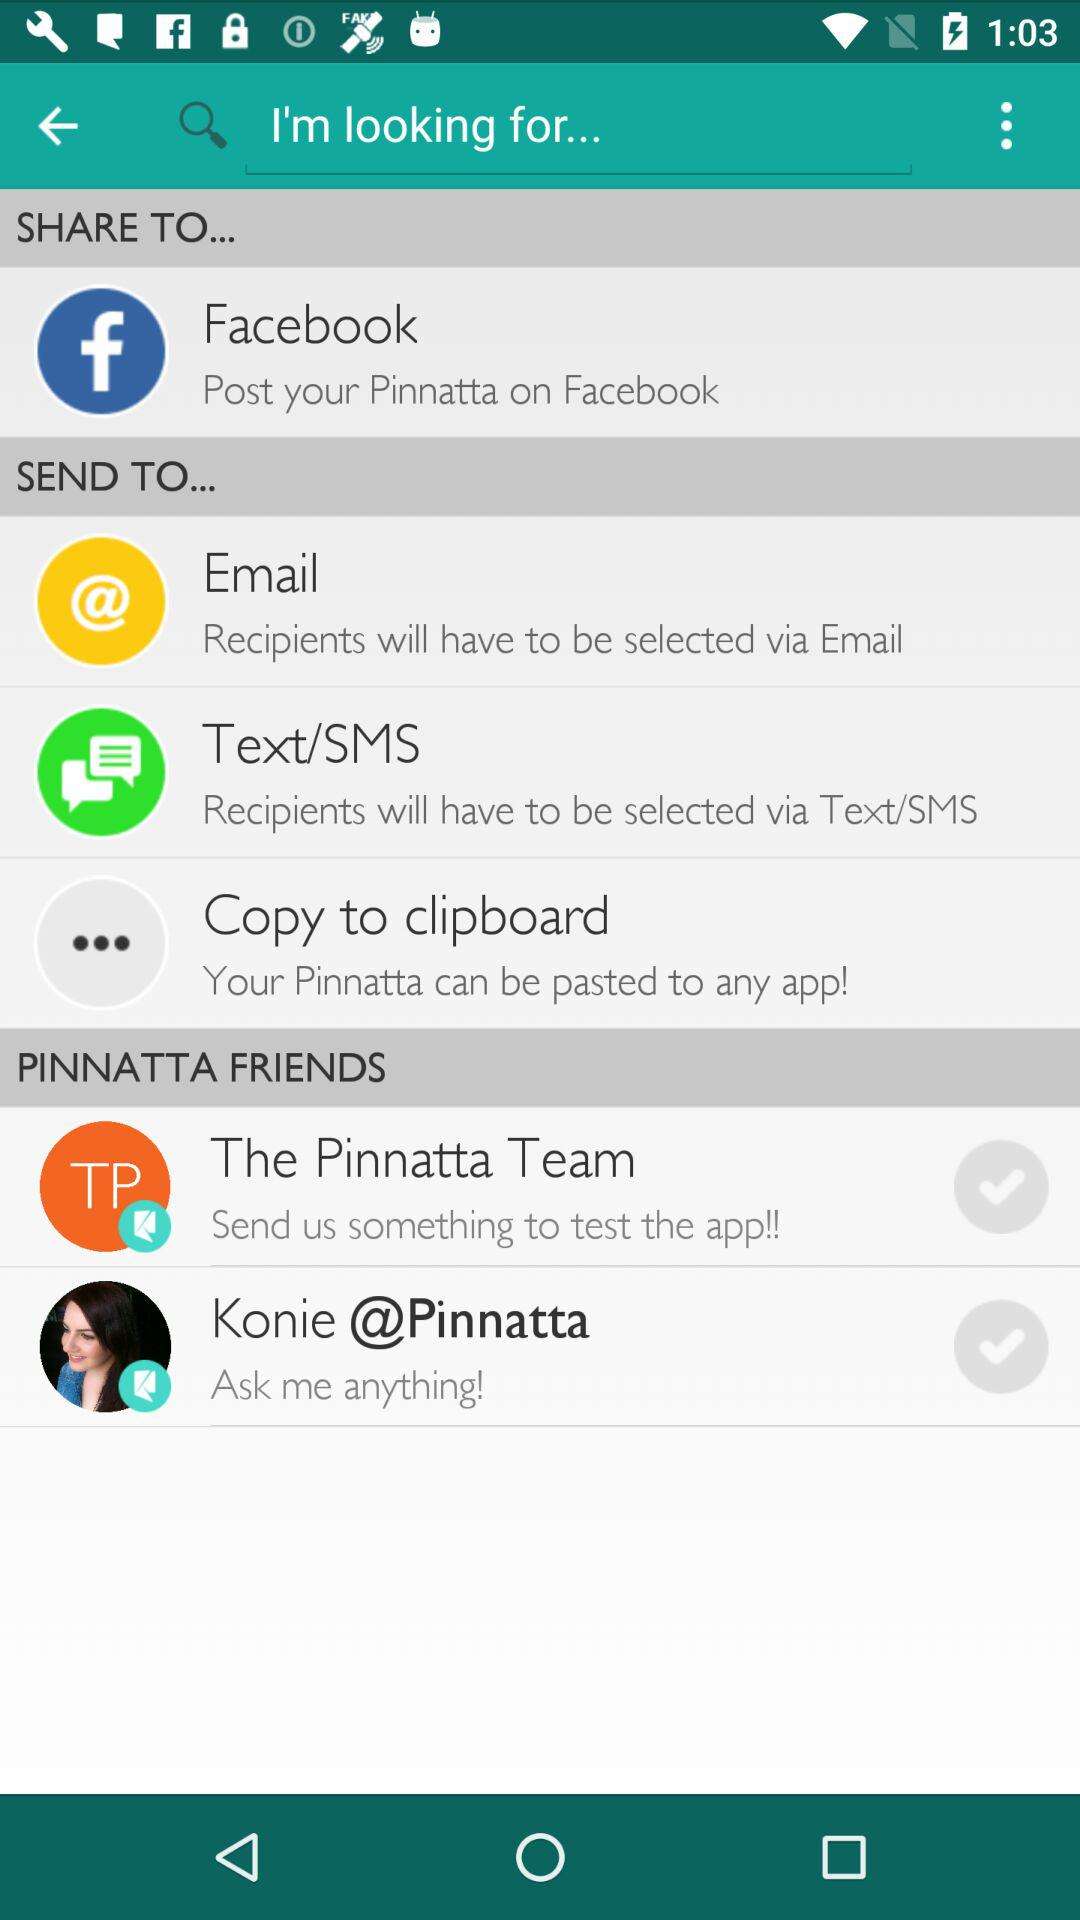What are the groups shown for Pinnatta Friends? The groups shown for Pinnatta Friends are: "The Pinnatta Team" and "Konie @Pinnatta". 